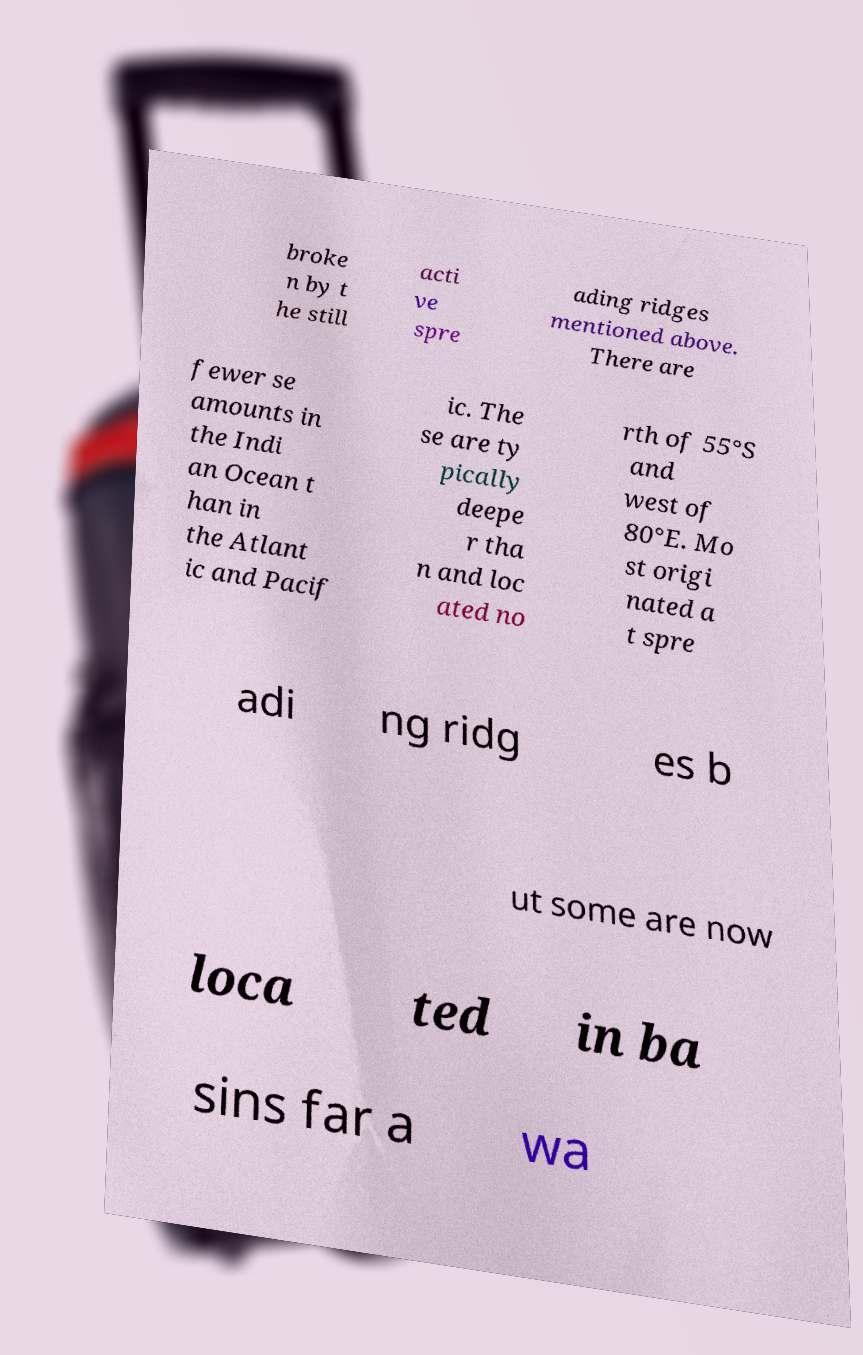Could you extract and type out the text from this image? broke n by t he still acti ve spre ading ridges mentioned above. There are fewer se amounts in the Indi an Ocean t han in the Atlant ic and Pacif ic. The se are ty pically deepe r tha n and loc ated no rth of 55°S and west of 80°E. Mo st origi nated a t spre adi ng ridg es b ut some are now loca ted in ba sins far a wa 